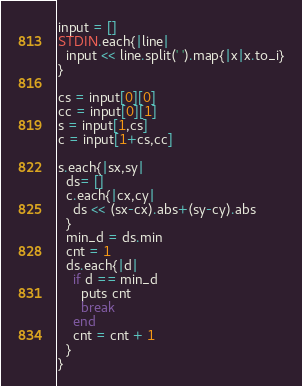<code> <loc_0><loc_0><loc_500><loc_500><_Ruby_>input = []
STDIN.each{|line|
  input << line.split(' ').map{|x|x.to_i}
}

cs = input[0][0]
cc = input[0][1]
s = input[1,cs]
c = input[1+cs,cc]

s.each{|sx,sy|
  ds= []
  c.each{|cx,cy|
    ds << (sx-cx).abs+(sy-cy).abs
  }
  min_d = ds.min
  cnt = 1
  ds.each{|d|
    if d == min_d
      puts cnt
      break
    end
    cnt = cnt + 1
  }
}
</code> 